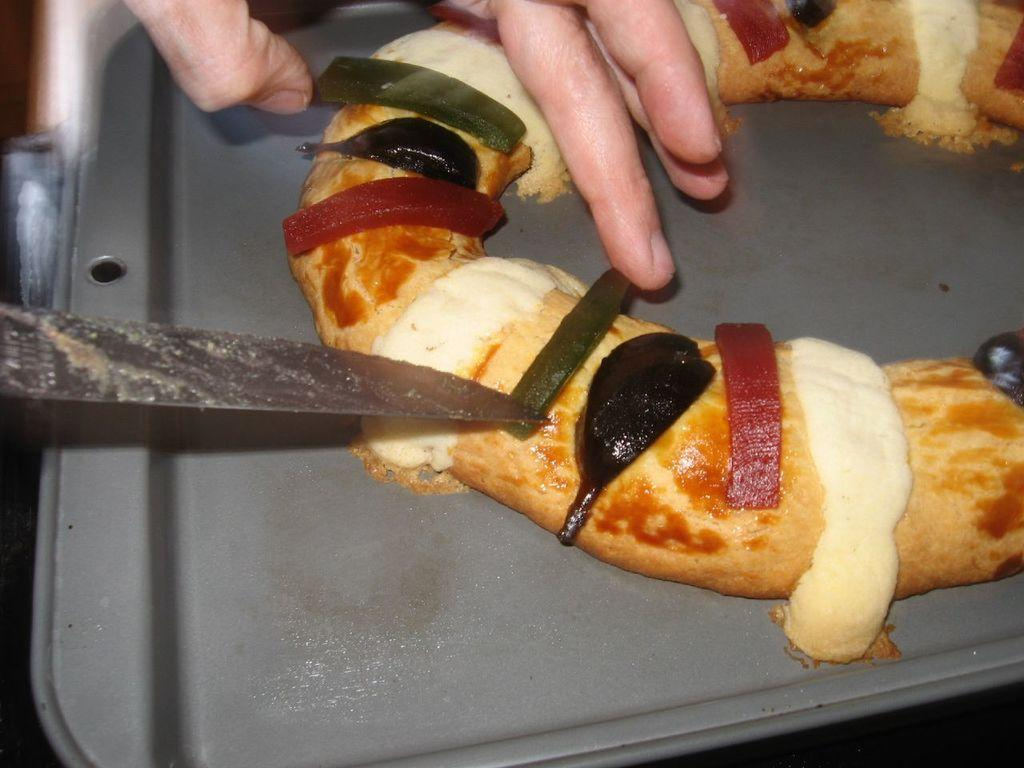What part of a person can be seen in the image? There is a hand of a person in the image. What object is present in the image that could be used for cutting? There is a knife in the image. What is on the tray in the image? There is food on a tray in the image. How many people are in the crowd surrounding the hand in the image? There is no crowd present in the image; it only shows a hand and a knife. What type of wood is the blade made of in the image? There is no blade present in the image, only a knife. 